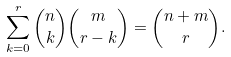<formula> <loc_0><loc_0><loc_500><loc_500>\sum _ { k = 0 } ^ { r } \binom { n } { k } \binom { m } { r - k } = \binom { n + m } { r } .</formula> 